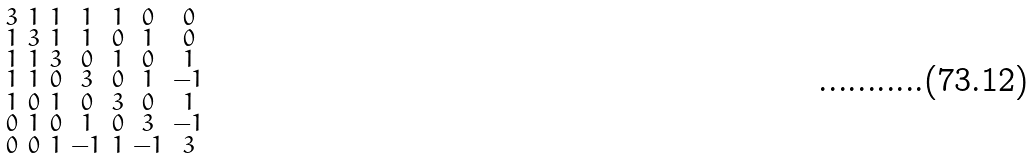Convert formula to latex. <formula><loc_0><loc_0><loc_500><loc_500>\begin{smallmatrix} 3 & 1 & 1 & 1 & 1 & 0 & 0 \\ 1 & 3 & 1 & 1 & 0 & 1 & 0 \\ 1 & 1 & 3 & 0 & 1 & 0 & 1 \\ 1 & 1 & 0 & 3 & 0 & 1 & - 1 \\ 1 & 0 & 1 & 0 & 3 & 0 & 1 \\ 0 & 1 & 0 & 1 & 0 & 3 & - 1 \\ 0 & 0 & 1 & - 1 & 1 & - 1 & 3 \end{smallmatrix}</formula> 